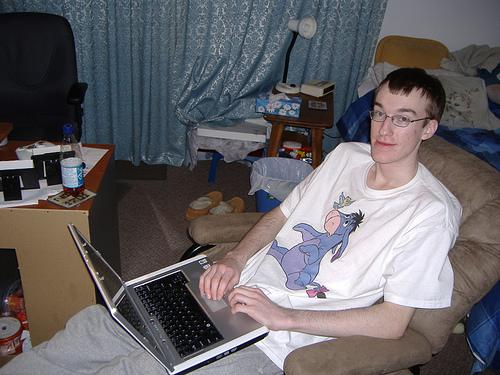What is the can to his side primarily used for? trash 